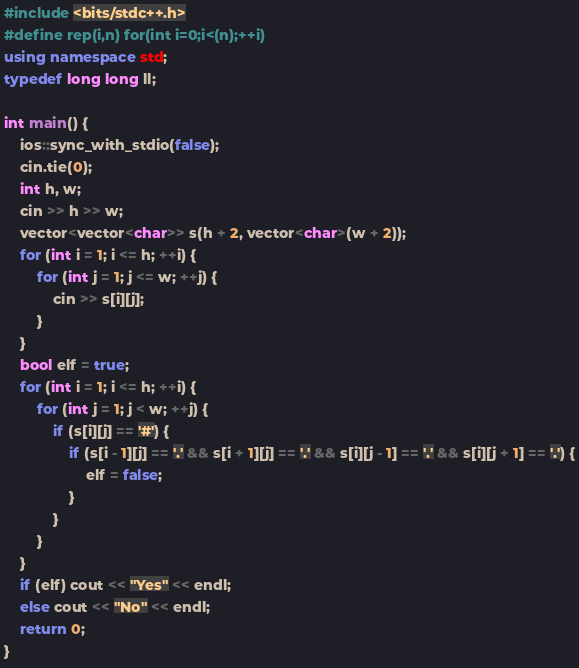Convert code to text. <code><loc_0><loc_0><loc_500><loc_500><_C++_>#include <bits/stdc++.h>
#define rep(i,n) for(int i=0;i<(n);++i)
using namespace std;
typedef long long ll;

int main() {
	ios::sync_with_stdio(false);
	cin.tie(0);
	int h, w;
	cin >> h >> w;
	vector<vector<char>> s(h + 2, vector<char>(w + 2));
	for (int i = 1; i <= h; ++i) {
		for (int j = 1; j <= w; ++j) {
			cin >> s[i][j];
		}
	}
	bool elf = true;
	for (int i = 1; i <= h; ++i) {
		for (int j = 1; j < w; ++j) {
			if (s[i][j] == '#') {
				if (s[i - 1][j] == '.' && s[i + 1][j] == '.' && s[i][j - 1] == '.' && s[i][j + 1] == '.') {
					elf = false;
				}
			}
		}
	}
	if (elf) cout << "Yes" << endl;
	else cout << "No" << endl;
	return 0;
}</code> 